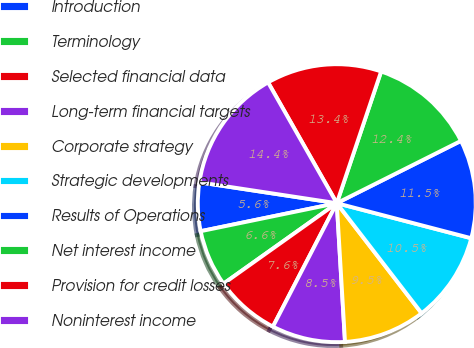Convert chart. <chart><loc_0><loc_0><loc_500><loc_500><pie_chart><fcel>Introduction<fcel>Terminology<fcel>Selected financial data<fcel>Long-term financial targets<fcel>Corporate strategy<fcel>Strategic developments<fcel>Results of Operations<fcel>Net interest income<fcel>Provision for credit losses<fcel>Noninterest income<nl><fcel>5.63%<fcel>6.6%<fcel>7.57%<fcel>8.54%<fcel>9.51%<fcel>10.49%<fcel>11.46%<fcel>12.43%<fcel>13.4%<fcel>14.37%<nl></chart> 